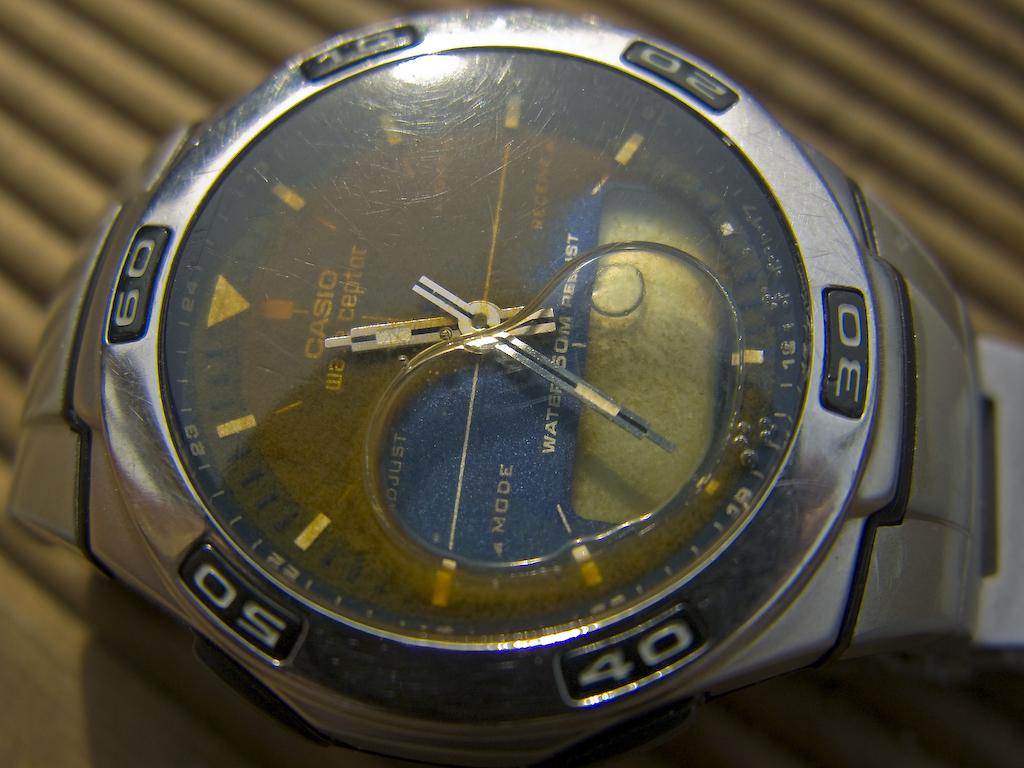What is the time displayed?
Offer a terse response. 11:35. 